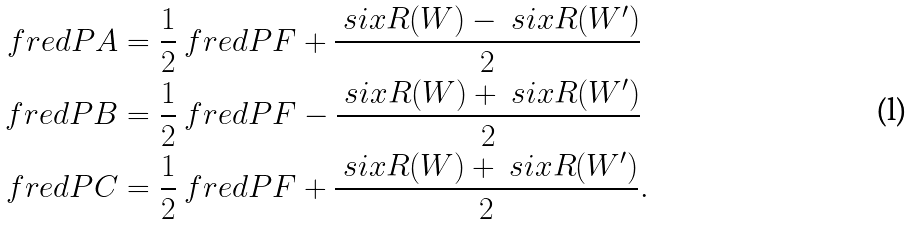<formula> <loc_0><loc_0><loc_500><loc_500>\ f r e d P { A } & = \frac { 1 } { 2 } \ f r e d P { F } + \frac { \ s i x R ( W ) - \ s i x R ( W ^ { \prime } ) } { 2 } \\ \ f r e d P { B } & = \frac { 1 } { 2 } \ f r e d P { F } - \frac { \ s i x R ( W ) + \ s i x R ( W ^ { \prime } ) } { 2 } \\ \ f r e d P { C } & = \frac { 1 } { 2 } \ f r e d P { F } + \frac { \ s i x R ( W ) + \ s i x R ( W ^ { \prime } ) } { 2 } .</formula> 